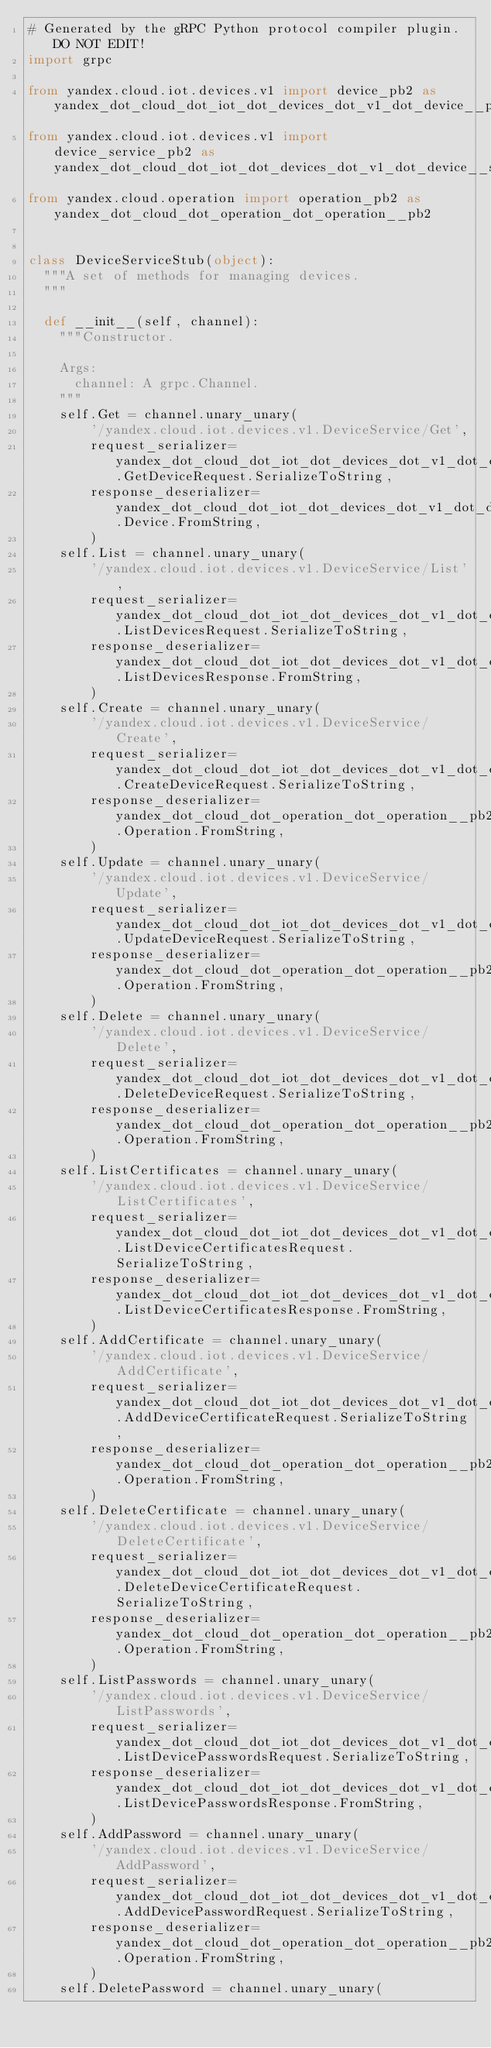Convert code to text. <code><loc_0><loc_0><loc_500><loc_500><_Python_># Generated by the gRPC Python protocol compiler plugin. DO NOT EDIT!
import grpc

from yandex.cloud.iot.devices.v1 import device_pb2 as yandex_dot_cloud_dot_iot_dot_devices_dot_v1_dot_device__pb2
from yandex.cloud.iot.devices.v1 import device_service_pb2 as yandex_dot_cloud_dot_iot_dot_devices_dot_v1_dot_device__service__pb2
from yandex.cloud.operation import operation_pb2 as yandex_dot_cloud_dot_operation_dot_operation__pb2


class DeviceServiceStub(object):
  """A set of methods for managing devices.
  """

  def __init__(self, channel):
    """Constructor.

    Args:
      channel: A grpc.Channel.
    """
    self.Get = channel.unary_unary(
        '/yandex.cloud.iot.devices.v1.DeviceService/Get',
        request_serializer=yandex_dot_cloud_dot_iot_dot_devices_dot_v1_dot_device__service__pb2.GetDeviceRequest.SerializeToString,
        response_deserializer=yandex_dot_cloud_dot_iot_dot_devices_dot_v1_dot_device__pb2.Device.FromString,
        )
    self.List = channel.unary_unary(
        '/yandex.cloud.iot.devices.v1.DeviceService/List',
        request_serializer=yandex_dot_cloud_dot_iot_dot_devices_dot_v1_dot_device__service__pb2.ListDevicesRequest.SerializeToString,
        response_deserializer=yandex_dot_cloud_dot_iot_dot_devices_dot_v1_dot_device__service__pb2.ListDevicesResponse.FromString,
        )
    self.Create = channel.unary_unary(
        '/yandex.cloud.iot.devices.v1.DeviceService/Create',
        request_serializer=yandex_dot_cloud_dot_iot_dot_devices_dot_v1_dot_device__service__pb2.CreateDeviceRequest.SerializeToString,
        response_deserializer=yandex_dot_cloud_dot_operation_dot_operation__pb2.Operation.FromString,
        )
    self.Update = channel.unary_unary(
        '/yandex.cloud.iot.devices.v1.DeviceService/Update',
        request_serializer=yandex_dot_cloud_dot_iot_dot_devices_dot_v1_dot_device__service__pb2.UpdateDeviceRequest.SerializeToString,
        response_deserializer=yandex_dot_cloud_dot_operation_dot_operation__pb2.Operation.FromString,
        )
    self.Delete = channel.unary_unary(
        '/yandex.cloud.iot.devices.v1.DeviceService/Delete',
        request_serializer=yandex_dot_cloud_dot_iot_dot_devices_dot_v1_dot_device__service__pb2.DeleteDeviceRequest.SerializeToString,
        response_deserializer=yandex_dot_cloud_dot_operation_dot_operation__pb2.Operation.FromString,
        )
    self.ListCertificates = channel.unary_unary(
        '/yandex.cloud.iot.devices.v1.DeviceService/ListCertificates',
        request_serializer=yandex_dot_cloud_dot_iot_dot_devices_dot_v1_dot_device__service__pb2.ListDeviceCertificatesRequest.SerializeToString,
        response_deserializer=yandex_dot_cloud_dot_iot_dot_devices_dot_v1_dot_device__service__pb2.ListDeviceCertificatesResponse.FromString,
        )
    self.AddCertificate = channel.unary_unary(
        '/yandex.cloud.iot.devices.v1.DeviceService/AddCertificate',
        request_serializer=yandex_dot_cloud_dot_iot_dot_devices_dot_v1_dot_device__service__pb2.AddDeviceCertificateRequest.SerializeToString,
        response_deserializer=yandex_dot_cloud_dot_operation_dot_operation__pb2.Operation.FromString,
        )
    self.DeleteCertificate = channel.unary_unary(
        '/yandex.cloud.iot.devices.v1.DeviceService/DeleteCertificate',
        request_serializer=yandex_dot_cloud_dot_iot_dot_devices_dot_v1_dot_device__service__pb2.DeleteDeviceCertificateRequest.SerializeToString,
        response_deserializer=yandex_dot_cloud_dot_operation_dot_operation__pb2.Operation.FromString,
        )
    self.ListPasswords = channel.unary_unary(
        '/yandex.cloud.iot.devices.v1.DeviceService/ListPasswords',
        request_serializer=yandex_dot_cloud_dot_iot_dot_devices_dot_v1_dot_device__service__pb2.ListDevicePasswordsRequest.SerializeToString,
        response_deserializer=yandex_dot_cloud_dot_iot_dot_devices_dot_v1_dot_device__service__pb2.ListDevicePasswordsResponse.FromString,
        )
    self.AddPassword = channel.unary_unary(
        '/yandex.cloud.iot.devices.v1.DeviceService/AddPassword',
        request_serializer=yandex_dot_cloud_dot_iot_dot_devices_dot_v1_dot_device__service__pb2.AddDevicePasswordRequest.SerializeToString,
        response_deserializer=yandex_dot_cloud_dot_operation_dot_operation__pb2.Operation.FromString,
        )
    self.DeletePassword = channel.unary_unary(</code> 